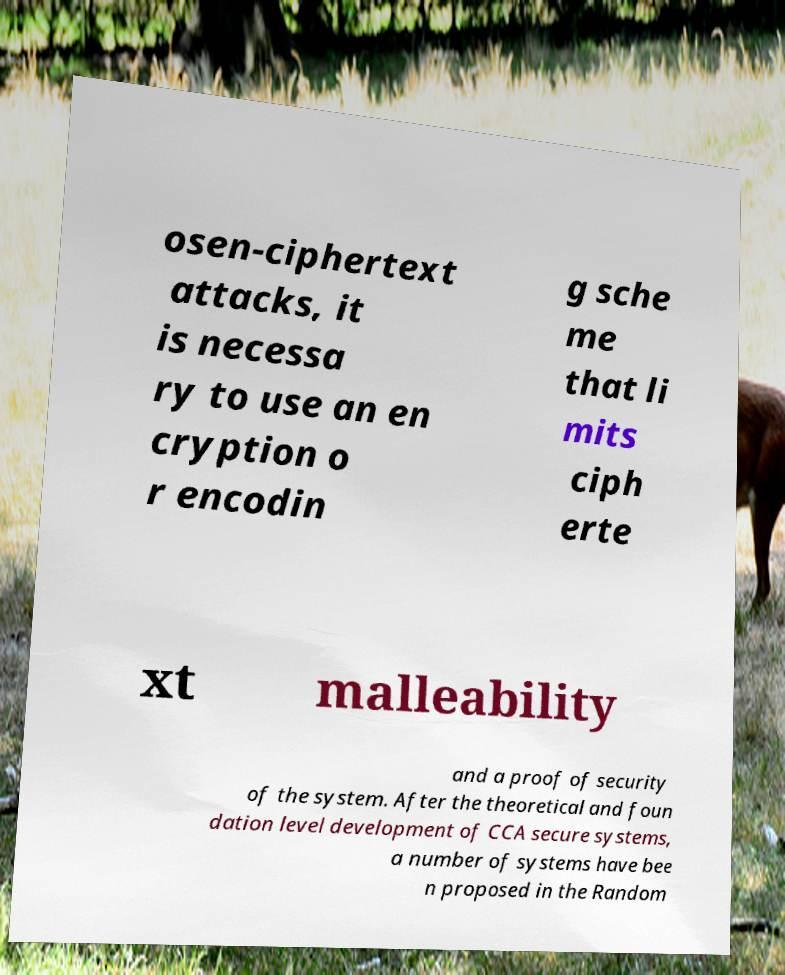Please identify and transcribe the text found in this image. osen-ciphertext attacks, it is necessa ry to use an en cryption o r encodin g sche me that li mits ciph erte xt malleability and a proof of security of the system. After the theoretical and foun dation level development of CCA secure systems, a number of systems have bee n proposed in the Random 